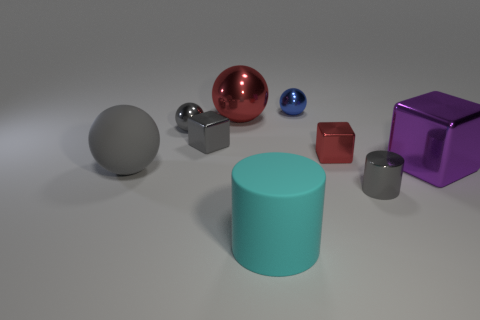What number of other things are there of the same size as the gray metal block?
Provide a succinct answer. 4. There is a gray object that is the same shape as the big cyan matte thing; what is its material?
Provide a short and direct response. Metal. What color is the big metallic ball?
Your answer should be compact. Red. What is the color of the large rubber object that is behind the tiny metal thing that is in front of the big purple cube?
Keep it short and to the point. Gray. There is a shiny cylinder; is it the same color as the large metal thing that is to the left of the purple object?
Your answer should be compact. No. How many gray rubber spheres are behind the big matte object that is in front of the gray metallic cylinder behind the cyan cylinder?
Your answer should be compact. 1. Are there any tiny red metallic blocks on the left side of the gray cube?
Offer a terse response. No. Is there any other thing that has the same color as the rubber ball?
Your response must be concise. Yes. What number of balls are either large purple things or cyan objects?
Provide a short and direct response. 0. What number of large objects are both behind the cyan cylinder and to the left of the gray cylinder?
Give a very brief answer. 2. 